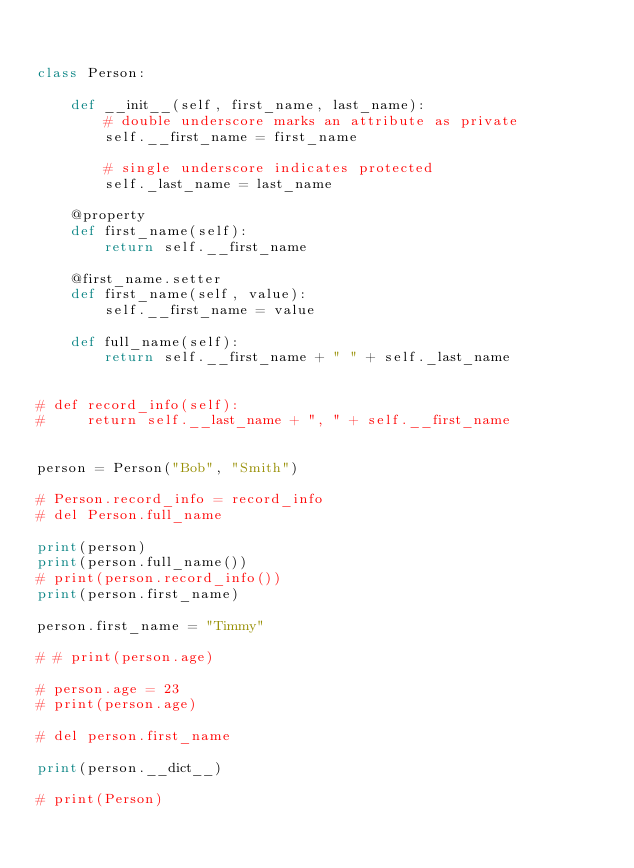<code> <loc_0><loc_0><loc_500><loc_500><_Python_>

class Person:

    def __init__(self, first_name, last_name):
        # double underscore marks an attribute as private
        self.__first_name = first_name

        # single underscore indicates protected
        self._last_name = last_name

    @property
    def first_name(self):
        return self.__first_name

    @first_name.setter
    def first_name(self, value):
        self.__first_name = value

    def full_name(self):
        return self.__first_name + " " + self._last_name


# def record_info(self):
#     return self.__last_name + ", " + self.__first_name


person = Person("Bob", "Smith")

# Person.record_info = record_info
# del Person.full_name

print(person)
print(person.full_name())
# print(person.record_info())
print(person.first_name)

person.first_name = "Timmy"

# # print(person.age)

# person.age = 23
# print(person.age)

# del person.first_name

print(person.__dict__)

# print(Person)
</code> 